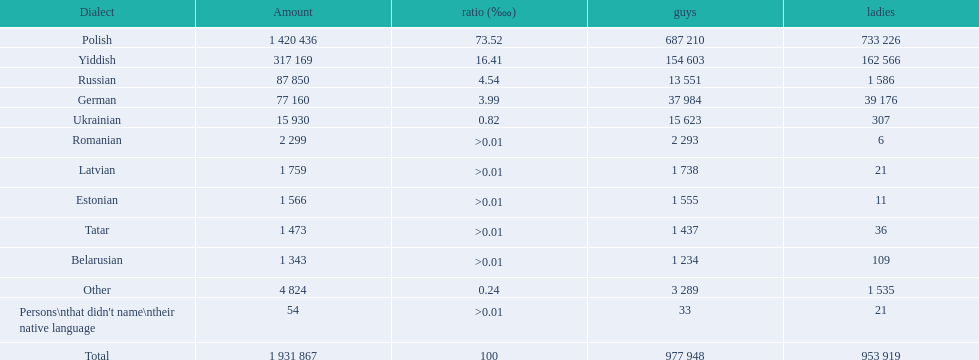What are all the spoken languages? Polish, Yiddish, Russian, German, Ukrainian, Romanian, Latvian, Estonian, Tatar, Belarusian. Which one of these has the most people speaking it? Polish. 